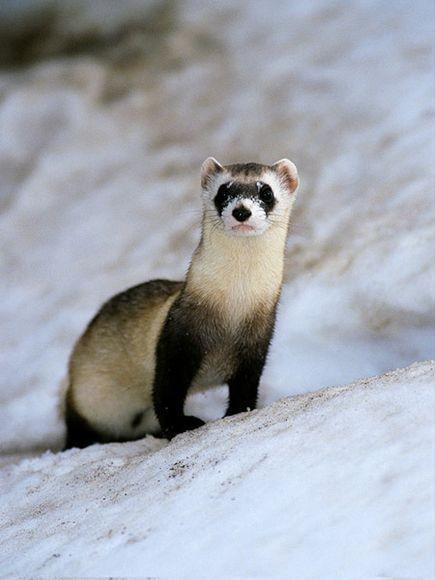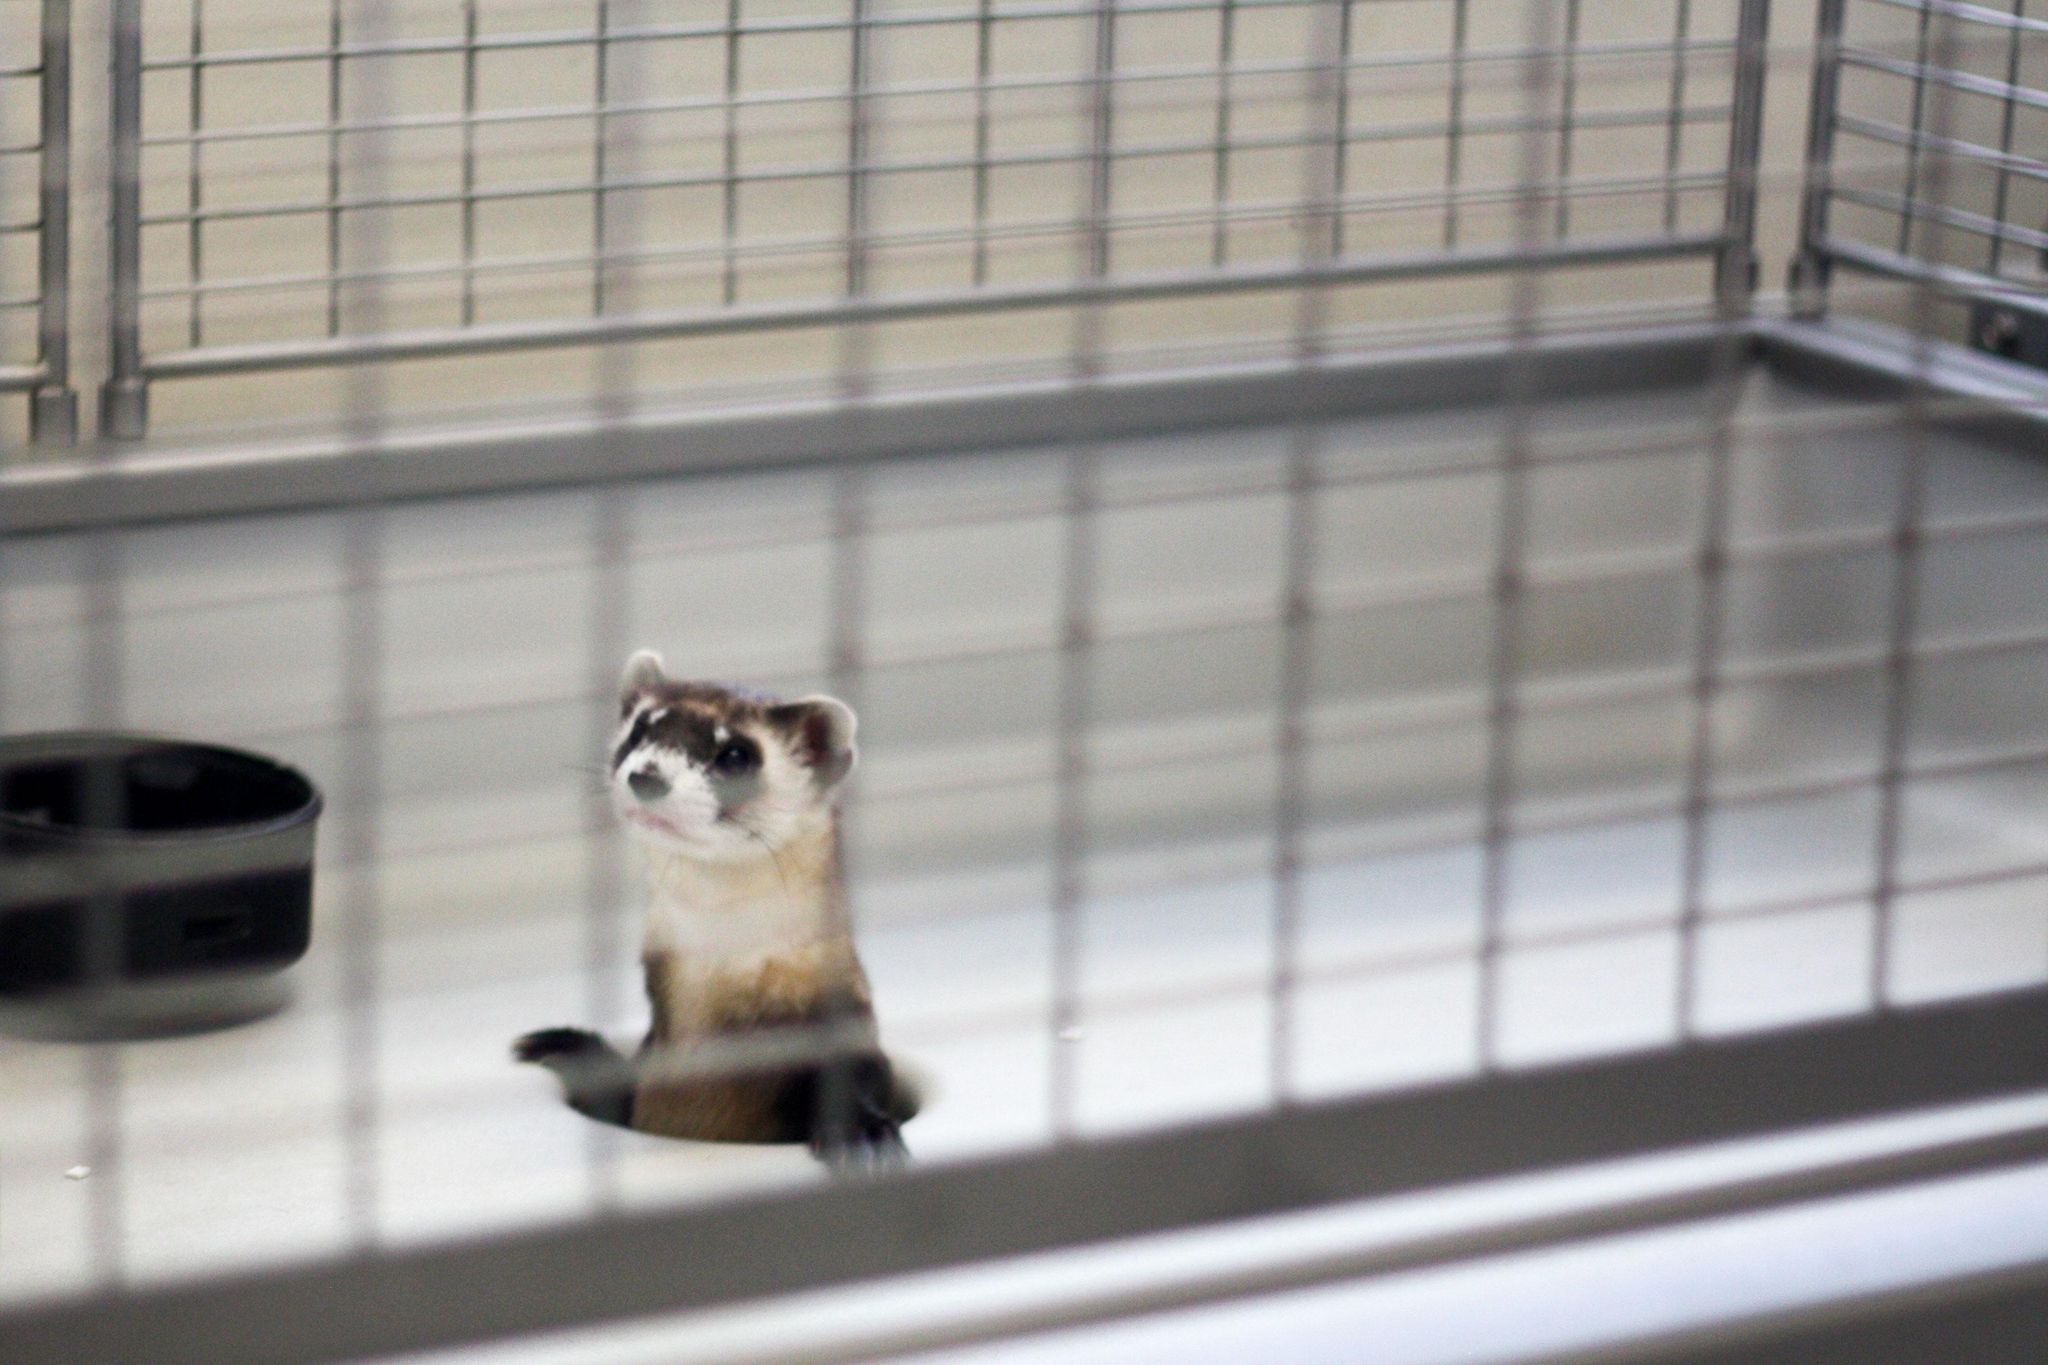The first image is the image on the left, the second image is the image on the right. Evaluate the accuracy of this statement regarding the images: "A ferret is popping up through a hole inside a metal wire cage.". Is it true? Answer yes or no. Yes. 